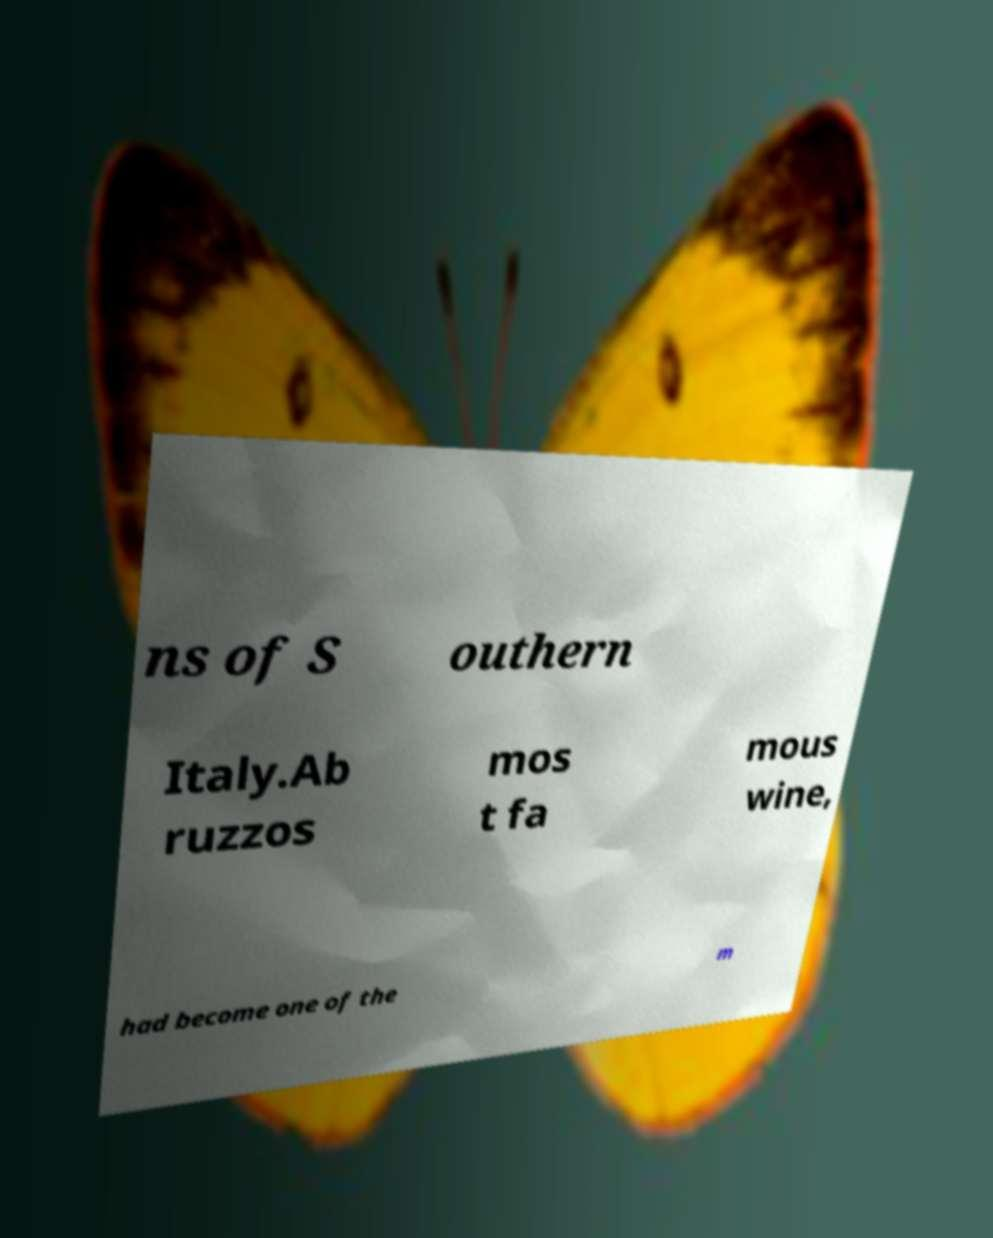There's text embedded in this image that I need extracted. Can you transcribe it verbatim? ns of S outhern Italy.Ab ruzzos mos t fa mous wine, had become one of the m 